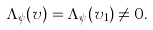<formula> <loc_0><loc_0><loc_500><loc_500>\Lambda _ { \psi } ( v ) = \Lambda _ { \psi } ( v _ { 1 } ) \neq 0 .</formula> 